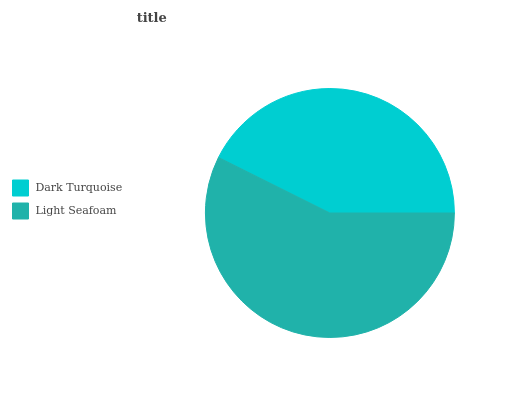Is Dark Turquoise the minimum?
Answer yes or no. Yes. Is Light Seafoam the maximum?
Answer yes or no. Yes. Is Light Seafoam the minimum?
Answer yes or no. No. Is Light Seafoam greater than Dark Turquoise?
Answer yes or no. Yes. Is Dark Turquoise less than Light Seafoam?
Answer yes or no. Yes. Is Dark Turquoise greater than Light Seafoam?
Answer yes or no. No. Is Light Seafoam less than Dark Turquoise?
Answer yes or no. No. Is Light Seafoam the high median?
Answer yes or no. Yes. Is Dark Turquoise the low median?
Answer yes or no. Yes. Is Dark Turquoise the high median?
Answer yes or no. No. Is Light Seafoam the low median?
Answer yes or no. No. 